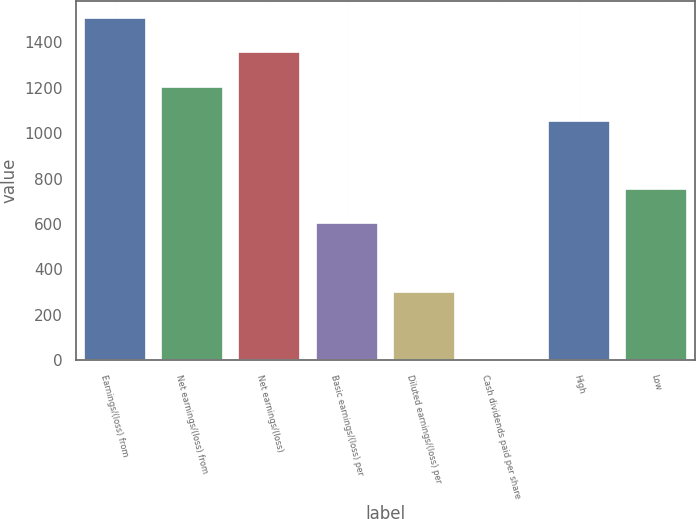<chart> <loc_0><loc_0><loc_500><loc_500><bar_chart><fcel>Earnings/(loss) from<fcel>Net earnings/(loss) from<fcel>Net earnings/(loss)<fcel>Basic earnings/(loss) per<fcel>Diluted earnings/(loss) per<fcel>Cash dividends paid per share<fcel>High<fcel>Low<nl><fcel>1506.03<fcel>1204.89<fcel>1355.46<fcel>602.62<fcel>301.49<fcel>0.35<fcel>1054.33<fcel>753.19<nl></chart> 